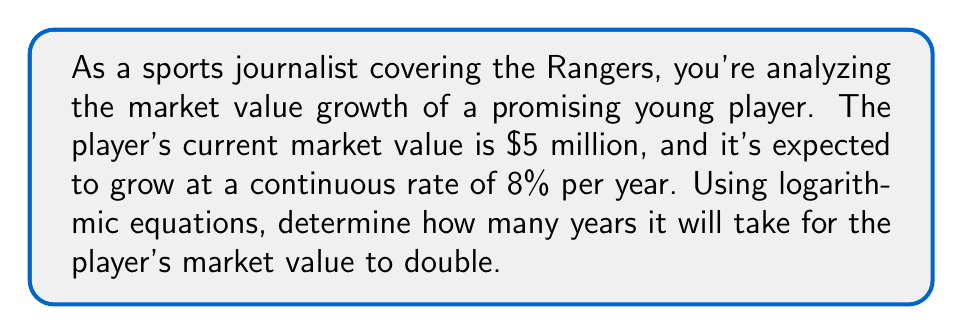Can you answer this question? To solve this problem, we'll use the continuous compound interest formula and logarithms. Let's break it down step-by-step:

1) The continuous compound interest formula is:
   $$A = P e^{rt}$$
   Where:
   $A$ = final amount
   $P$ = initial principal balance
   $e$ = Euler's number (approximately 2.71828)
   $r$ = interest rate (as a decimal)
   $t$ = time in years

2) We want to find when the value doubles, so $A = 2P$. We can substitute this into our equation:
   $$2P = P e^{rt}$$

3) Divide both sides by $P$:
   $$2 = e^{rt}$$

4) Take the natural log of both sides:
   $$\ln(2) = \ln(e^{rt})$$

5) Using the logarithm property $\ln(e^x) = x$, we get:
   $$\ln(2) = rt$$

6) Solve for $t$:
   $$t = \frac{\ln(2)}{r}$$

7) Now, let's plug in our values. We know $r = 0.08$ (8% as a decimal):
   $$t = \frac{\ln(2)}{0.08}$$

8) Calculate the result:
   $$t \approx 8.66 \text{ years}$$

This means it will take approximately 8.66 years for the Rangers player's market value to double at a continuous growth rate of 8% per year.
Answer: $t \approx 8.66 \text{ years}$ 